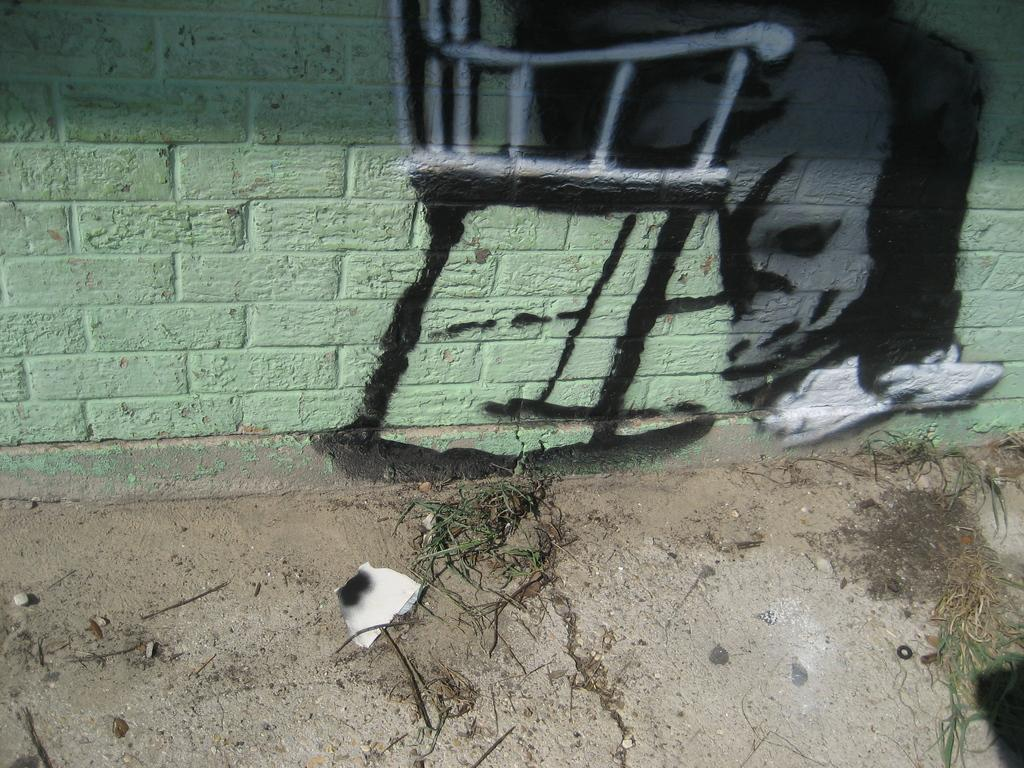What type of vegetation is present in the image? There is grass in the image. What color is the white object in the image? The white object in the image is white. What can be found on the ground in the image? There are sticks on the ground in the image. What is the color of the wall visible in the image? There is a green wall visible in the image. What is depicted on the green wall? There is a painting on the green wall. What type of insurance is being advertised on the painting in the image? There is no insurance being advertised in the image; the painting is not related to insurance. 